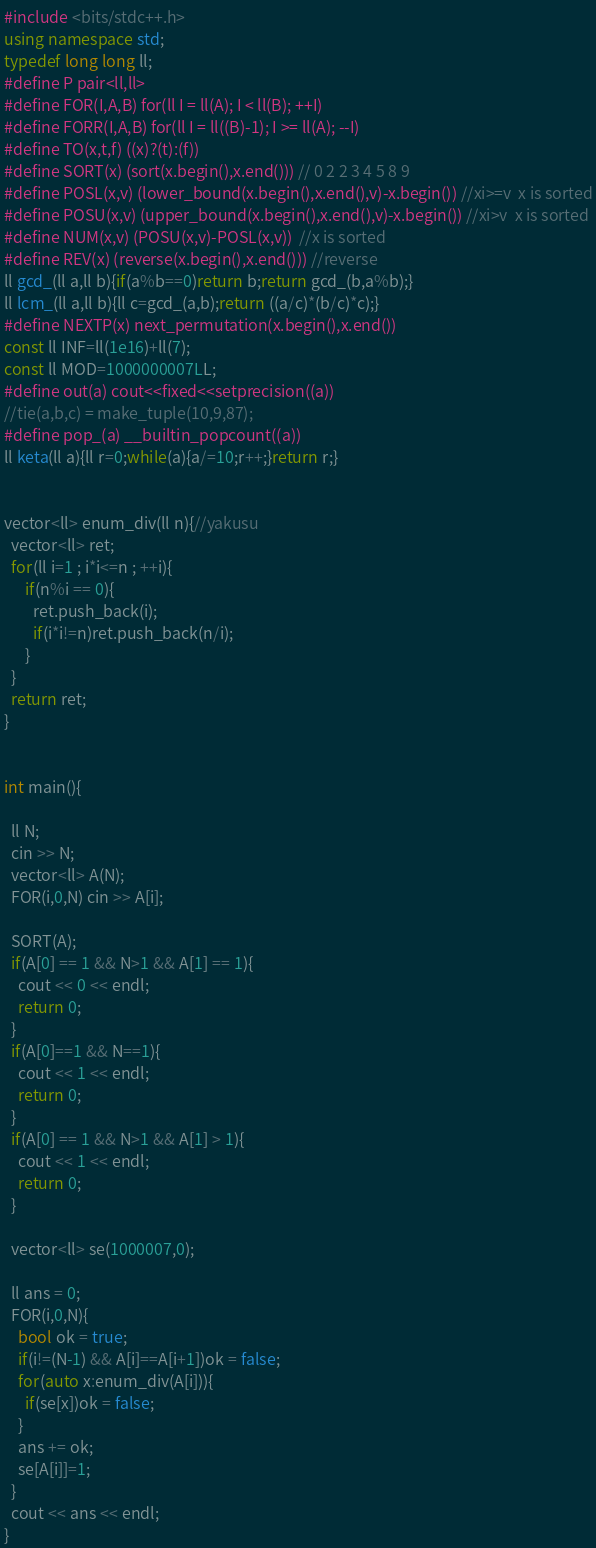Convert code to text. <code><loc_0><loc_0><loc_500><loc_500><_C++_>#include <bits/stdc++.h>
using namespace std;
typedef long long ll;
#define P pair<ll,ll>
#define FOR(I,A,B) for(ll I = ll(A); I < ll(B); ++I)
#define FORR(I,A,B) for(ll I = ll((B)-1); I >= ll(A); --I)
#define TO(x,t,f) ((x)?(t):(f))
#define SORT(x) (sort(x.begin(),x.end())) // 0 2 2 3 4 5 8 9
#define POSL(x,v) (lower_bound(x.begin(),x.end(),v)-x.begin()) //xi>=v  x is sorted
#define POSU(x,v) (upper_bound(x.begin(),x.end(),v)-x.begin()) //xi>v  x is sorted
#define NUM(x,v) (POSU(x,v)-POSL(x,v))  //x is sorted
#define REV(x) (reverse(x.begin(),x.end())) //reverse
ll gcd_(ll a,ll b){if(a%b==0)return b;return gcd_(b,a%b);}
ll lcm_(ll a,ll b){ll c=gcd_(a,b);return ((a/c)*(b/c)*c);}
#define NEXTP(x) next_permutation(x.begin(),x.end())
const ll INF=ll(1e16)+ll(7);
const ll MOD=1000000007LL;
#define out(a) cout<<fixed<<setprecision((a))
//tie(a,b,c) = make_tuple(10,9,87);
#define pop_(a) __builtin_popcount((a))
ll keta(ll a){ll r=0;while(a){a/=10;r++;}return r;}


vector<ll> enum_div(ll n){//yakusu
  vector<ll> ret;
  for(ll i=1 ; i*i<=n ; ++i){
      if(n%i == 0){
        ret.push_back(i);
        if(i*i!=n)ret.push_back(n/i);
      }
  }
  return ret;
}


int main(){

  ll N;
  cin >> N;
  vector<ll> A(N);
  FOR(i,0,N) cin >> A[i];

  SORT(A);
  if(A[0] == 1 && N>1 && A[1] == 1){
    cout << 0 << endl;
    return 0;
  }
  if(A[0]==1 && N==1){
    cout << 1 << endl;
    return 0;
  }
  if(A[0] == 1 && N>1 && A[1] > 1){
    cout << 1 << endl;
    return 0;
  }

  vector<ll> se(1000007,0);

  ll ans = 0;
  FOR(i,0,N){
    bool ok = true;
    if(i!=(N-1) && A[i]==A[i+1])ok = false;
    for(auto x:enum_div(A[i])){
      if(se[x])ok = false;
    }
    ans += ok;
    se[A[i]]=1;
  } 
  cout << ans << endl;
}

</code> 